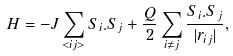Convert formula to latex. <formula><loc_0><loc_0><loc_500><loc_500>H = - J \sum _ { < i j > } { S } _ { i } { . } { S } _ { j } + \frac { Q } { 2 } \sum _ { i \neq j } \frac { { S } _ { i } { . } { S } _ { j } } { | { r } _ { i j } | } ,</formula> 